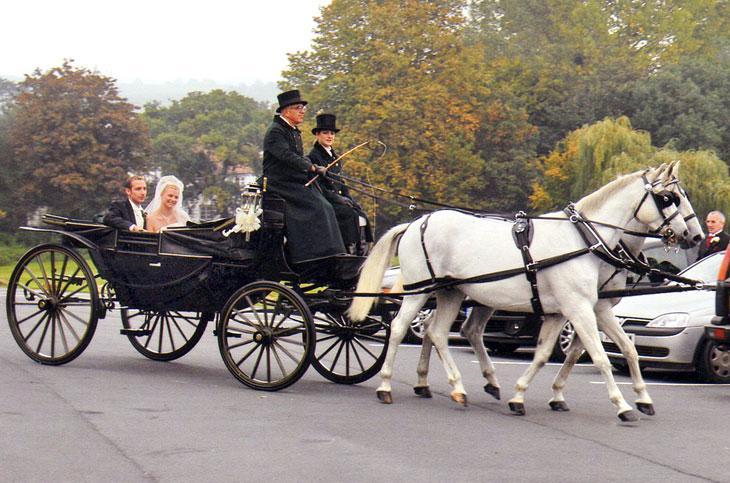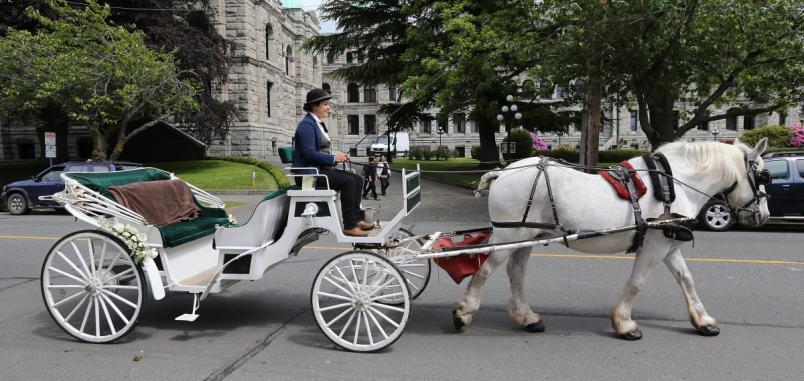The first image is the image on the left, the second image is the image on the right. Analyze the images presented: Is the assertion "The white carriage is being pulled by a black horse." valid? Answer yes or no. No. 